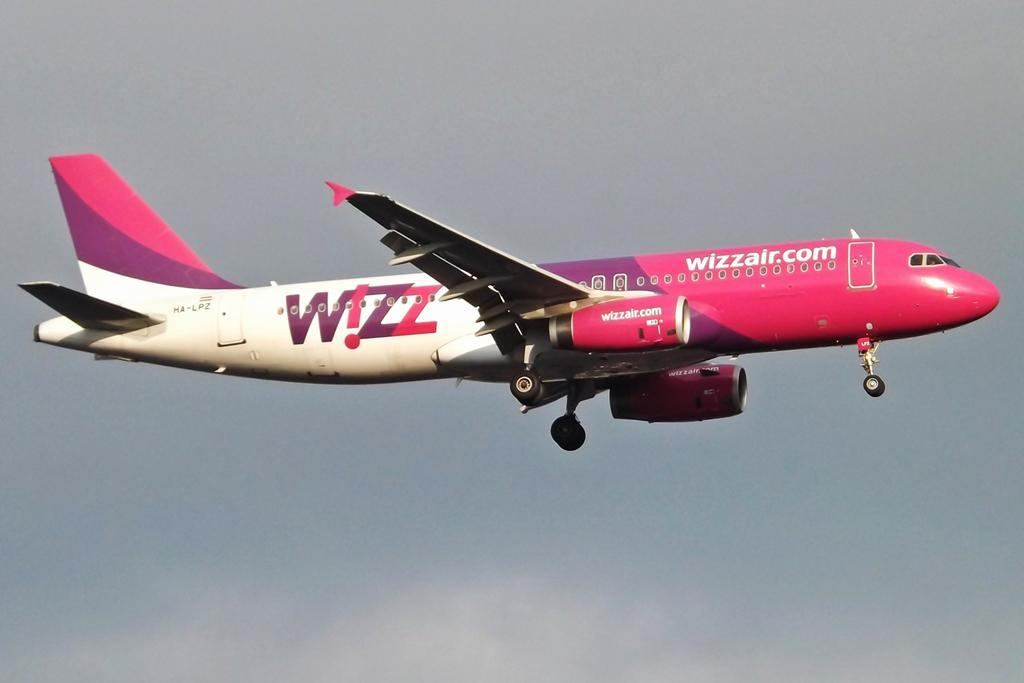<image>
Summarize the visual content of the image. A bright pink and white plane advertises for wizzair. 